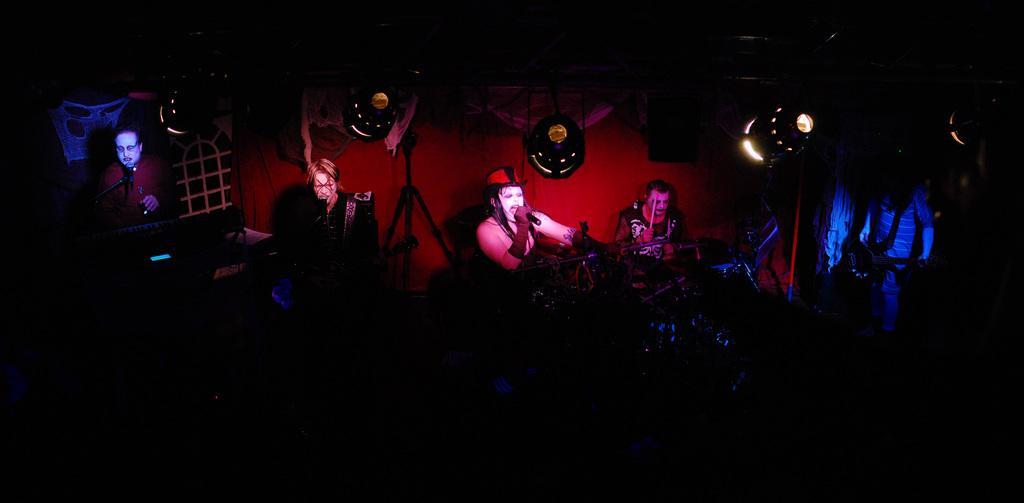How would you summarize this image in a sentence or two? In the center of the image we can see a few people are holding some objects and they are in different costumes. In the background there is a wall, lights, musical instruments and a few other objects. 